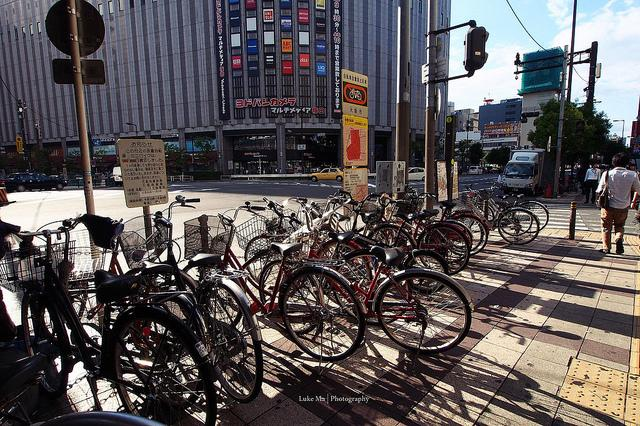Where are the owners of these bikes while this photo was taken? Please explain your reasoning. at work. They leave their bikes there while they work. 